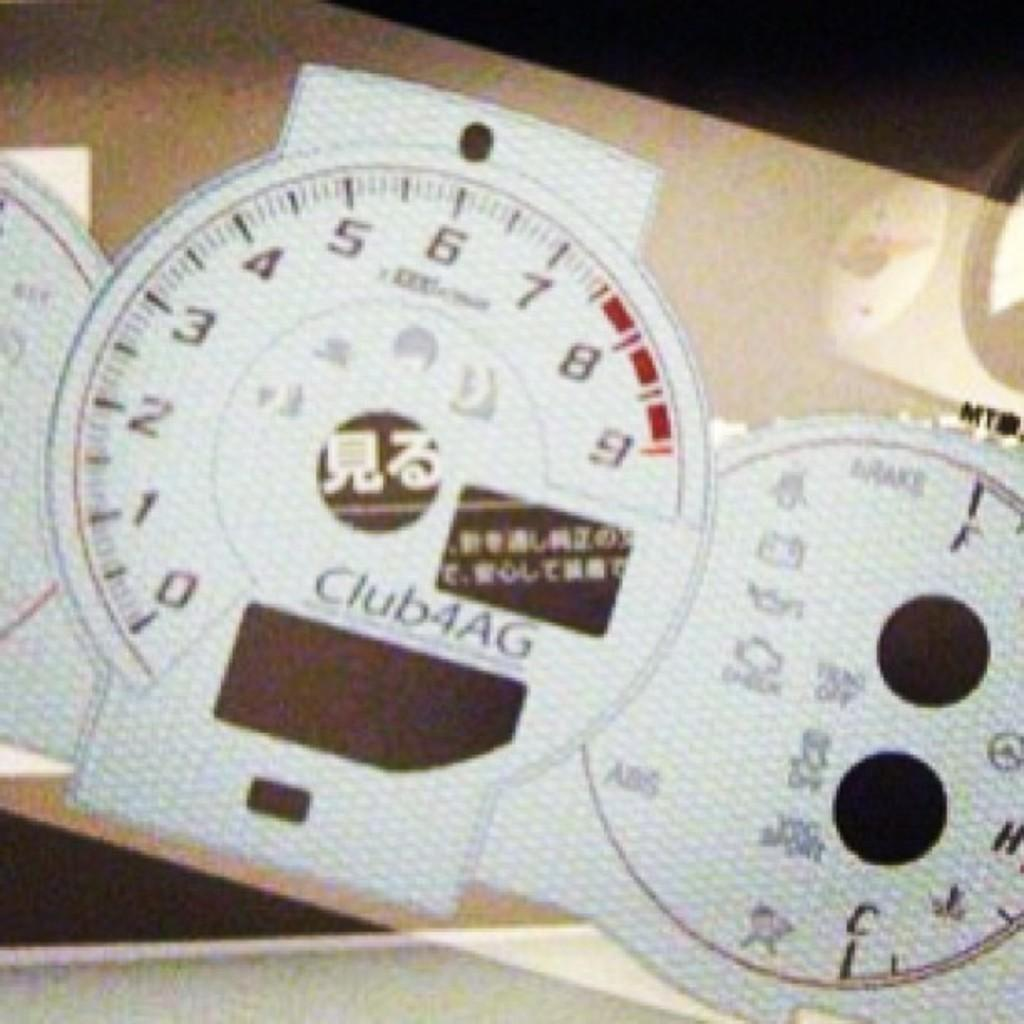What color are the objects in the image? The objects in the image are white. What is written on the white objects? Numbers and words are written on the white objects. What colors make up the background of the image? The background of the image is cream and black. How does the fog affect the visibility of the objects in the image? There is no fog present in the image, so it does not affect the visibility of the objects. 